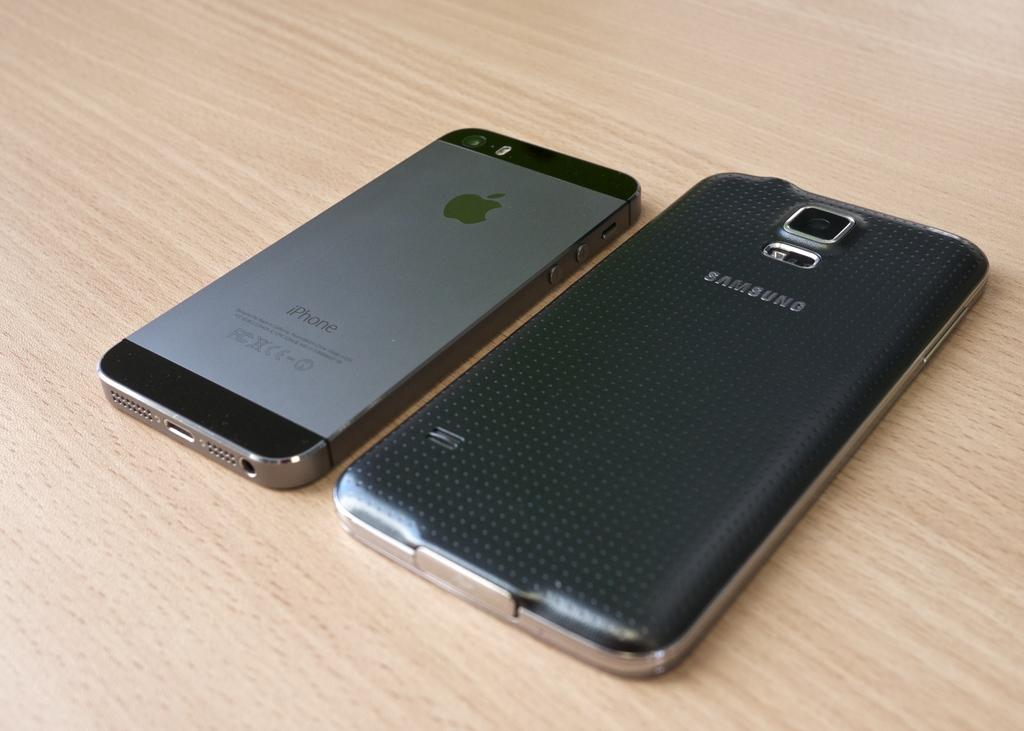What type of mobile phones are visible in the image? There is an iPhone and a Samsung mobile phone in the image. Where are the mobile phones located in the image? Both mobile phones are on a table in the image. What type of wire can be seen connecting the two mobile phones in the image? There is no wire connecting the two mobile phones in the image; they are simply placed on a table next to each other. Can you see a hill in the background of the image? There is no hill visible in the image; it only shows the two mobile phones on a table. 